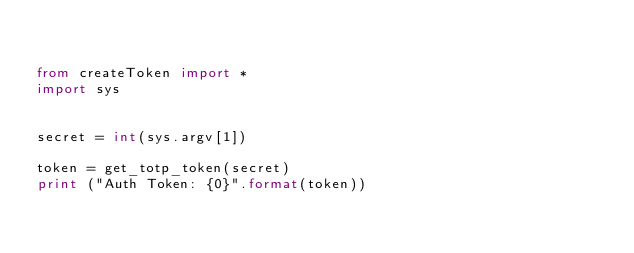<code> <loc_0><loc_0><loc_500><loc_500><_Python_>

from createToken import *
import sys


secret = int(sys.argv[1])

token = get_totp_token(secret)
print ("Auth Token: {0}".format(token))


</code> 